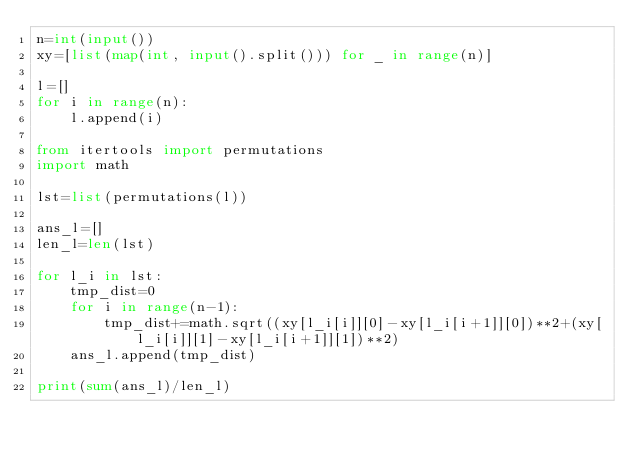<code> <loc_0><loc_0><loc_500><loc_500><_Python_>n=int(input())
xy=[list(map(int, input().split())) for _ in range(n)]

l=[]
for i in range(n):
    l.append(i)

from itertools import permutations
import math

lst=list(permutations(l))

ans_l=[]
len_l=len(lst)

for l_i in lst:
    tmp_dist=0
    for i in range(n-1):
        tmp_dist+=math.sqrt((xy[l_i[i]][0]-xy[l_i[i+1]][0])**2+(xy[l_i[i]][1]-xy[l_i[i+1]][1])**2)
    ans_l.append(tmp_dist)

print(sum(ans_l)/len_l)
</code> 